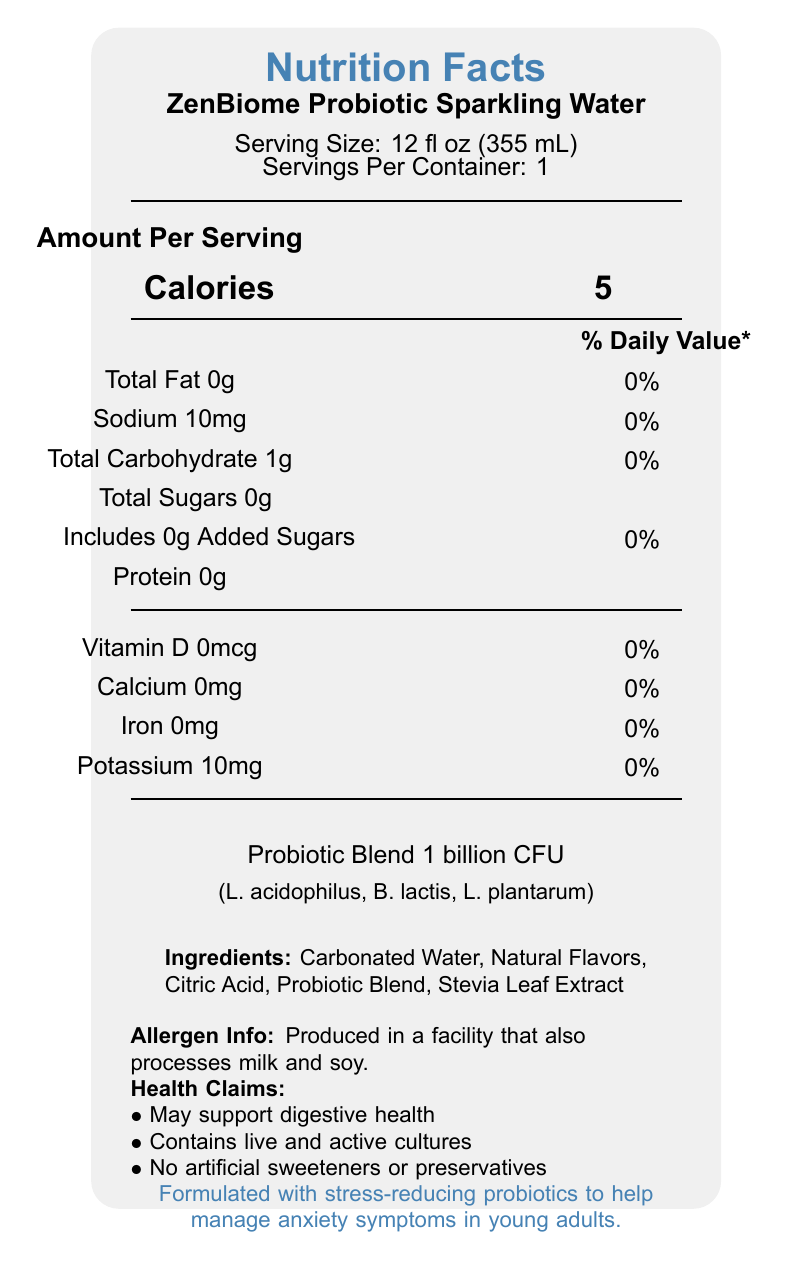what is the serving size of ZenBiome Probiotic Sparkling Water? The serving size is clearly mentioned near the top of the document as "Serving Size: 12 fl oz (355 mL)".
Answer: 12 fl oz (355 mL) how many calories are in one serving of ZenBiome Probiotic Sparkling Water? The document states "Calories 5" under the "Amount Per Serving" section.
Answer: 5 calories what are the strains included in the probiotic blend? The document lists the strains in the probiotic blend under the "Probiotic Blend 1 billion CFU" section.
Answer: Lactobacillus acidophilus, Bifidobacterium lactis, Lactobacillus plantarum how much sodium does one serving contain? The "Sodium 10mg" is listed in the nutritional content of the document.
Answer: 10mg what is the total carbohydrate content per serving? The document details the total carbohydrate content as "Total Carbohydrate 1g".
Answer: 1g which of the following is NOT an ingredient in ZenBiome Probiotic Sparkling Water?  
A. Citric Acid  
B. Ascorbic Acid  
C. Stevia Leaf Extract  
D. Carbonated Water The ingredients listed are Carbonated Water, Natural Flavors, Citric Acid, Probiotic Blend, and Stevia Leaf Extract. Ascorbic Acid is not mentioned.
Answer: B how many servings per container are there?  
1. 1  
2. 2  
3. 3  
4. 4 The document mentions "Servings Per Container: 1".
Answer: 1 does ZenBiome Probiotic Sparkling Water contain any added sugars? The total sugars are 0g, and it is noted that there are 0g of added sugars.
Answer: No is there any calcium in ZenBiome Probiotic Sparkling Water? The document states "Calcium 0mg".
Answer: No can the information provided determine how often the product should be consumed for managing anxiety symptoms? There is no specific information regarding the frequency of consumption required to manage anxiety symptoms in the document.
Answer: Cannot be determined does the product make any health claims? The document includes health claims such as "May support digestive health", "Contains live and active cultures", and "No artificial sweeteners or preservatives".
Answer: Yes summarize the main nutritional and health aspects of ZenBiome Probiotic Sparkling Water. The summary includes both the nutritional content (low calorie, no fat, no added sugars) and the health claims (probiotics for digestive health and anxiety management) mentioned in the document.
Answer: ZenBiome Probiotic Sparkling Water is a low-calorie beverage with 5 calories per serving. It contains no fat, added sugars, artificial sweeteners, or preservatives. It is infused with a probiotic blend totaling 1 billion CFU, including Lactobacillus acidophilus, Bifidobacterium lactis, and Lactobacillus plantarum, which may support digestive health. It also includes a statement about stress-reducing probiotics aimed at managing anxiety symptoms in young adults. does the document mention anything about the product containing artificial sweeteners or preservatives? There is a health claim clearly stating the product contains "No artificial sweeteners or preservatives".
Answer: No 